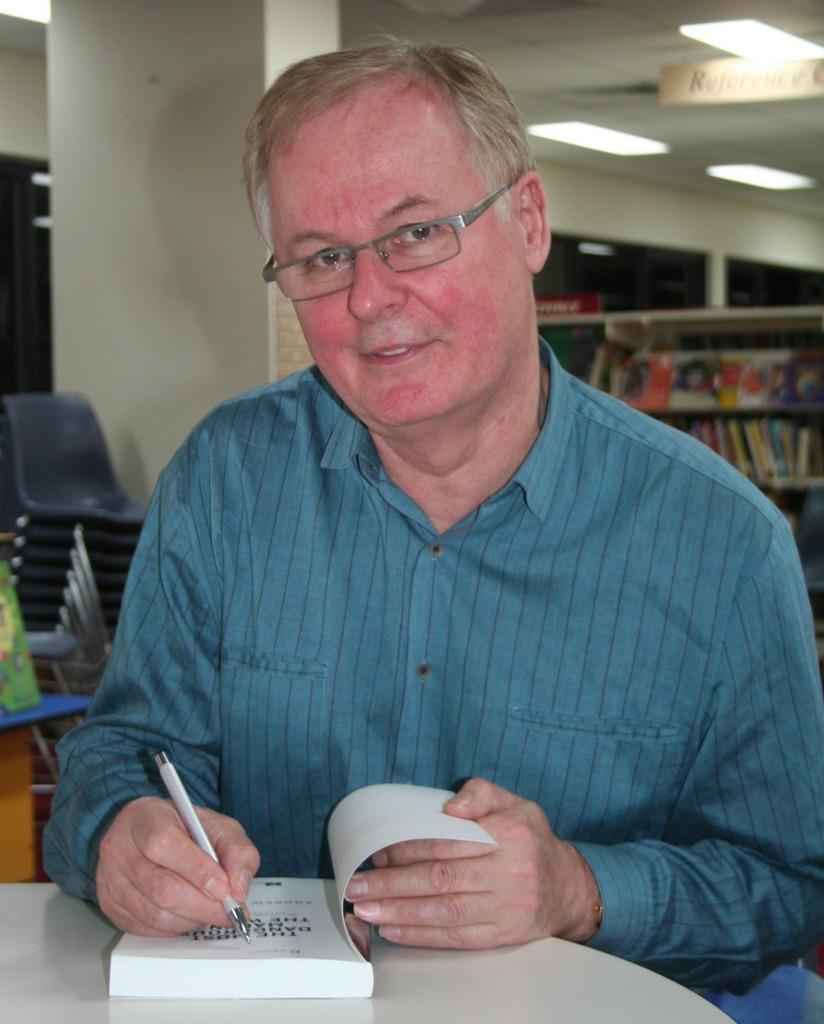What is the man in the image doing? The man is writing on a book in the image. What tool is the man using to write? The man is using a pen to write. What furniture is present in the image? There is a table and chairs in the image. What architectural feature can be seen in the image? There is a pillar in the image. What is stored on the racks in the image? There are books on the racks in the image. What surface is the board attached to in the image? The board is attached to the ceiling in the image. What type of lighting is present in the image? There are lights in the image. What type of invention is the man demonstrating in the image? There is no invention being demonstrated in the image; the man is simply writing on a book. Is the man wearing a mask in the image? No, the man is not wearing a mask in the image. 